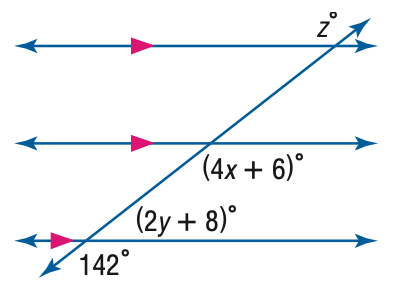Question: Find x in the figure.
Choices:
A. 15
B. 34
C. 39.5
D. 142
Answer with the letter. Answer: B Question: Find y in the figure.
Choices:
A. 15
B. 34
C. 67
D. 75
Answer with the letter. Answer: A Question: Find z in the figure.
Choices:
A. 132
B. 138
C. 142
D. 148
Answer with the letter. Answer: C 